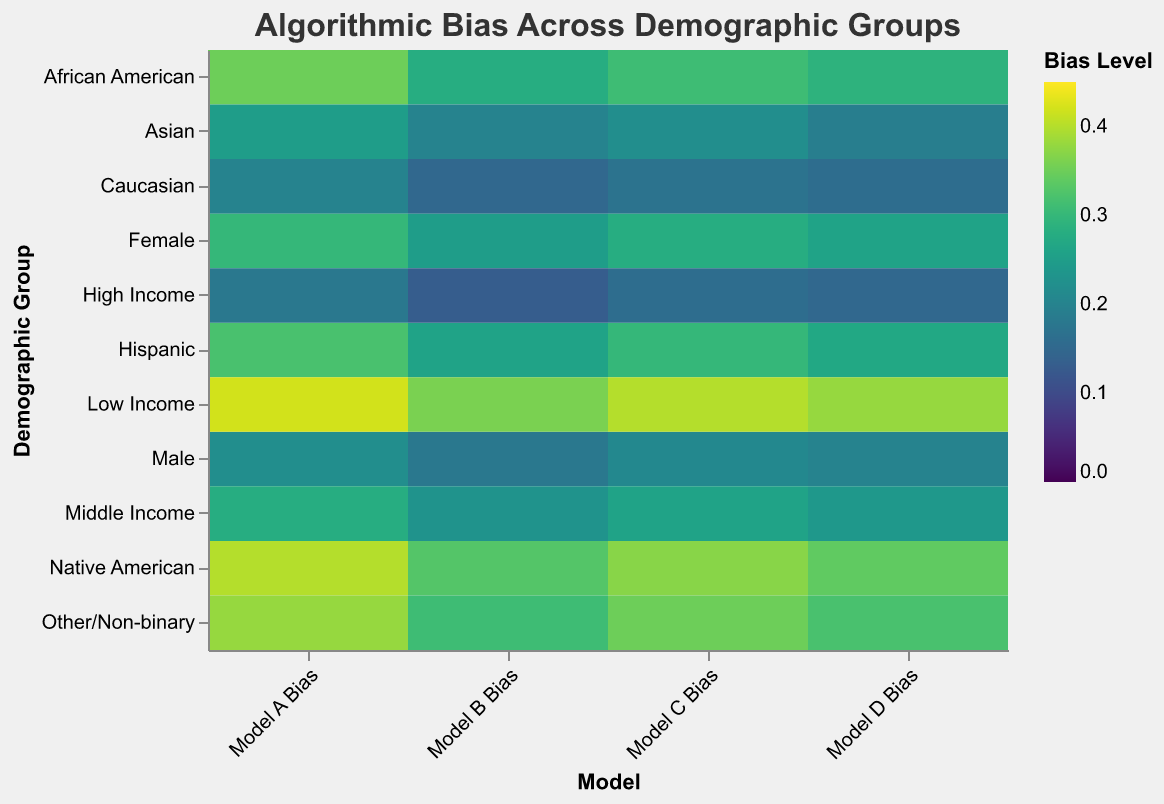What is the highest bias level observed for Model A? To determine the highest bias level for Model A, we scan through all the values in the "Model A Bias" column and identify the maximum value, which is 0.42 for the Low Income group.
Answer: 0.42 Which model has the lowest average bias across all demographic groups? To find the model with the lowest average bias, we need to calculate the average bias for each model:
Model A: (0.35 + 0.32 + 0.25 + 0.20 + 0.40 + 0.30 + 0.22 + 0.38 + 0.42 + 0.28 + 0.18) / 11 ≈ 0.299
Model B: (0.28 + 0.26 + 0.20 + 0.15 + 0.33 + 0.25 + 0.18 + 0.31 + 0.36 + 0.23 + 0.13) / 11 ≈ 0.241
Model C: (0.31 + 0.30 + 0.22 + 0.17 + 0.37 + 0.28 + 0.21 + 0.35 + 0.40 + 0.26 + 0.16) / 11 ≈ 0.276
Model D: (0.29 + 0.27 + 0.19 + 0.16 + 0.34 + 0.26 + 0.20 + 0.32 + 0.38 + 0.24 + 0.15) / 11 ≈ 0.250
Model B has the lowest average bias.
Answer: Model B Which demographic group has the highest bias in Model D? To find the demographic group with the highest bias in Model D, we look for the maximum value in the "Model D Bias" column and identify its corresponding group, which is Low Income with a bias level of 0.38.
Answer: Low Income What is the difference in bias levels between Model A and Model B for the Hispanic group? To find this difference, we subtract the bias level of Model B (0.26) from the bias level of Model A (0.32) for the Hispanic group, resulting in 0.06.
Answer: 0.06 What is the average bias level for the Male demographic group across all models? To find the average bias level for the Male demographic group, we sum the bias levels across all models and then divide by the number of models (4):
(0.22 + 0.18 + 0.21 + 0.20) / 4 = 0.2025
Answer: 0.2025 How does the bias level for the High Income group in Model A compare to Model C? We compare the bias levels for the High Income group between Model A (0.18) and Model C (0.16). Model A has a higher bias level (0.18) compared to Model C.
Answer: Model A is higher Is there any group with a consistent bias level across all models? To determine this, we scan through each demographic group's bias levels across the models to see if any group has the same bias level for all models. No group has a consistent bias level across all models, as all groups show variation in their bias levels across different models.
Answer: No 